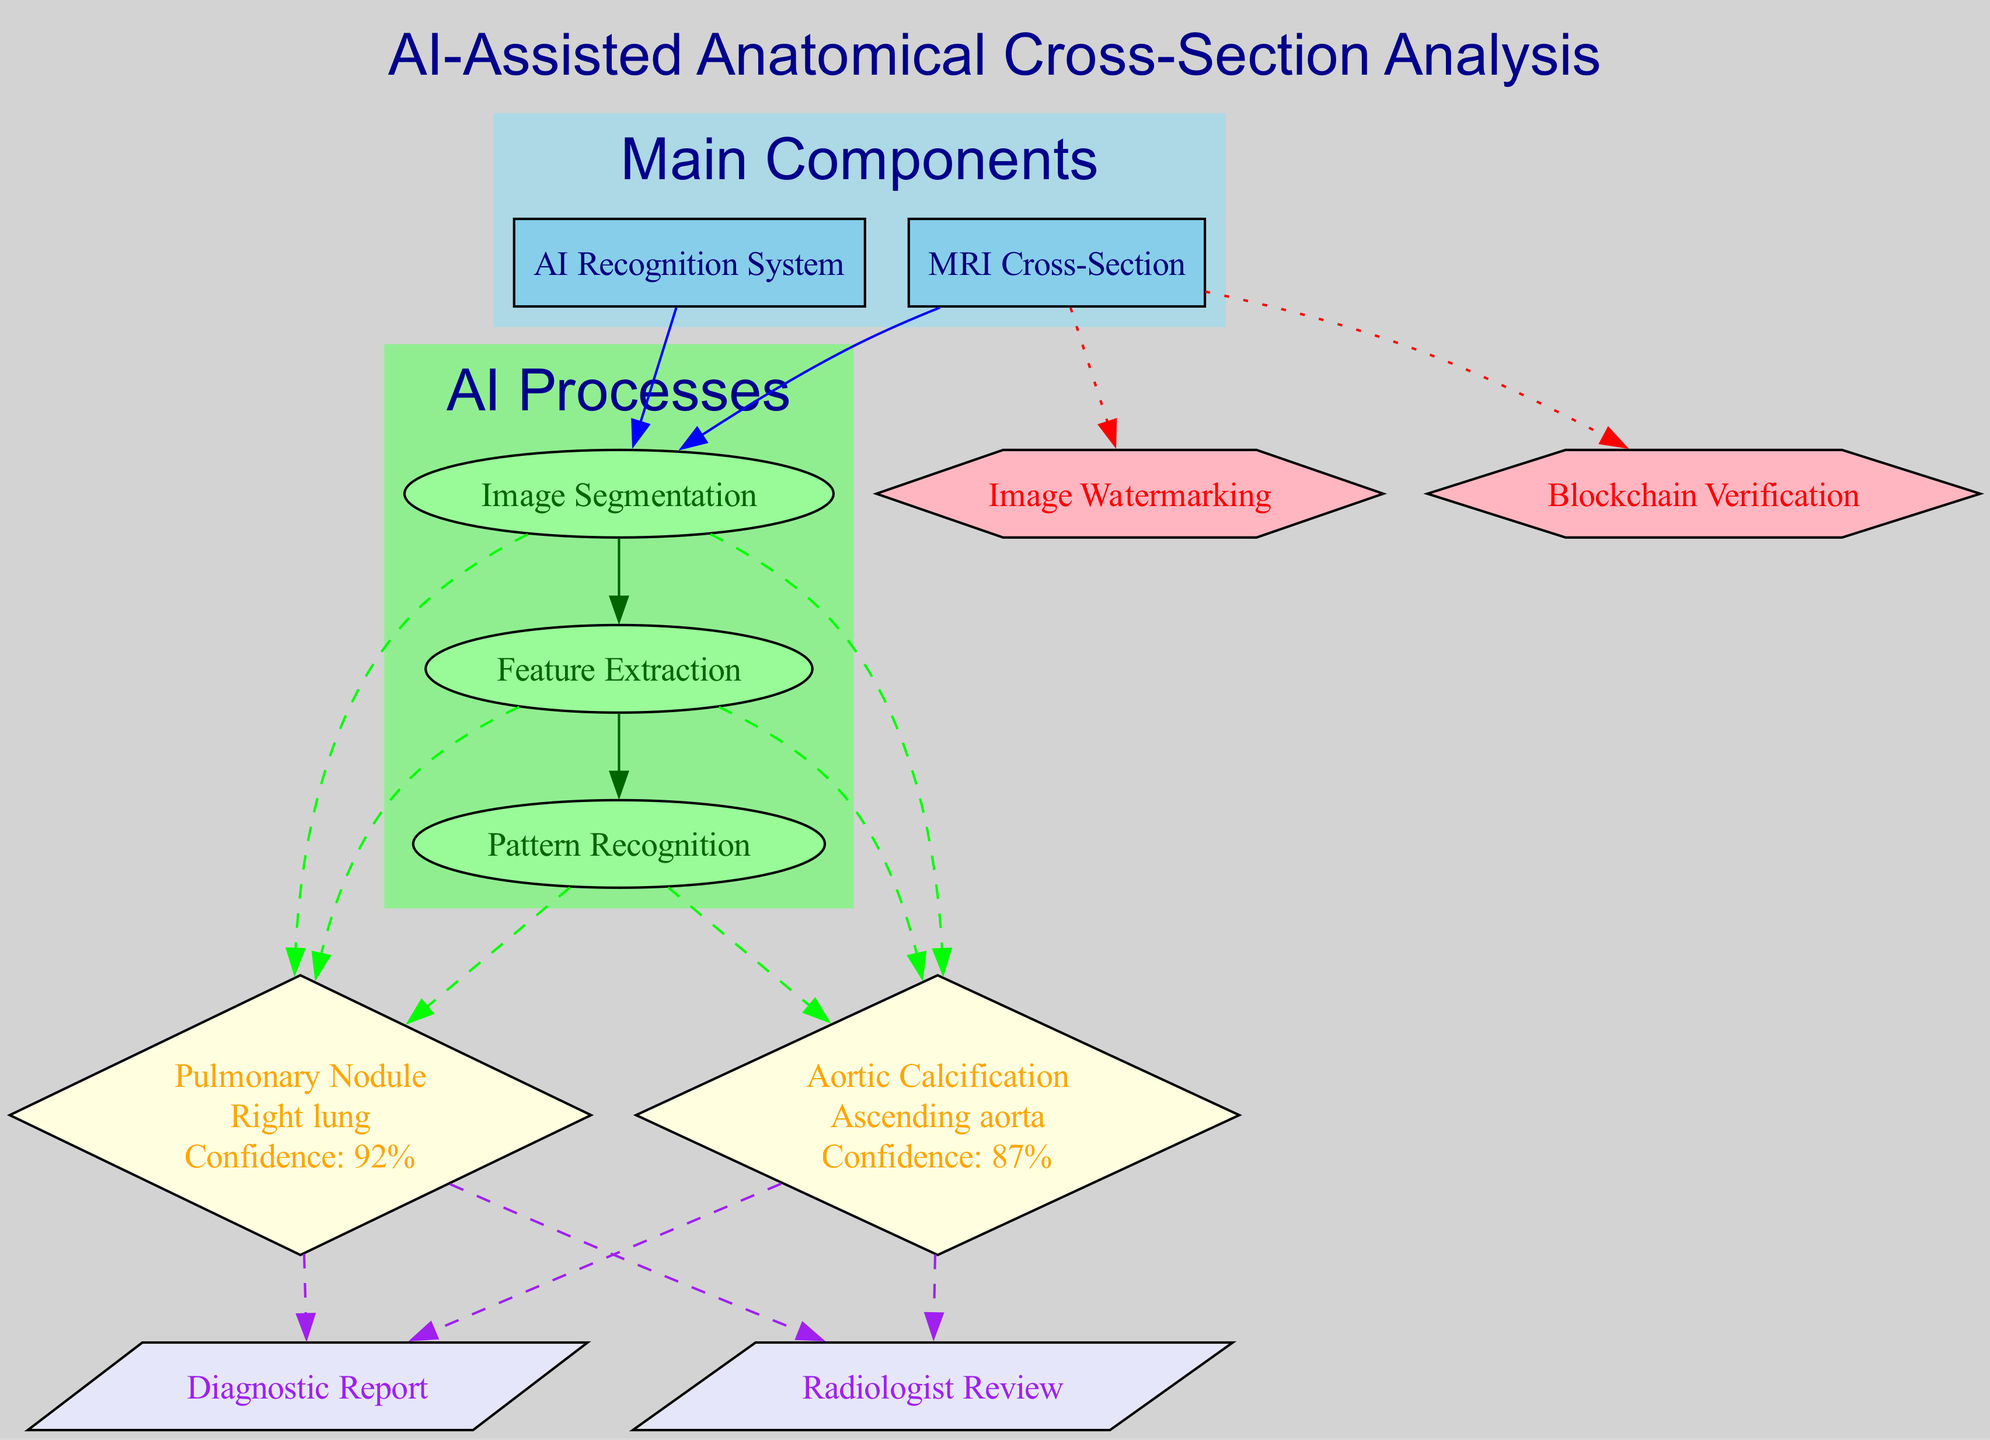What is the main component that includes a thoracic cavity slice? The diagram specifies "MRI Cross-Section" as one of the main components, indicating it represents a slice of the thoracic cavity.
Answer: MRI Cross-Section How many detected anomalies are shown in the diagram? The diagram lists two detected anomalies: "Pulmonary Nodule" and "Aortic Calcification," making the total count two.
Answer: 2 What is the AI confidence level for the pulmonary nodule? The diagram states that the AI confidence for the "Pulmonary Nodule" is 92%, clearly indicated next to its details.
Answer: 92% Which AI process follows image segmentation? According to the edges in the AI processes cluster, "Feature Extraction" comes directly after "Image Segmentation," indicating its sequential relation.
Answer: Feature Extraction What is the shape of the nodes used for detected anomalies? The diagram uses diamond-shaped nodes for indicating detected anomalies, which is a distinct feature in the structure.
Answer: Diamond Which component is responsible for generating human expert validations? The "Radiologist Review" node in the output section specifies that it is responsible for the human expert validation process.
Answer: Radiologist Review What is the relationship between AI processes and detected anomalies? The diagram shows that each AI process connects with detected anomalies through dashed lines, indicating a flow or interaction from the processes to the anomalies.
Answer: Dashed lines How many AI processes are illustrated in the diagram? The diagram lists three AI processes: "Image Segmentation," "Feature Extraction," and "Pattern Recognition," thus the total number is three.
Answer: 3 What does blockchain verification protect? The diagram identifies that "Blockchain Verification" serves to provide an immutable record of the image origin, denoting its specific protective function.
Answer: Image origin 